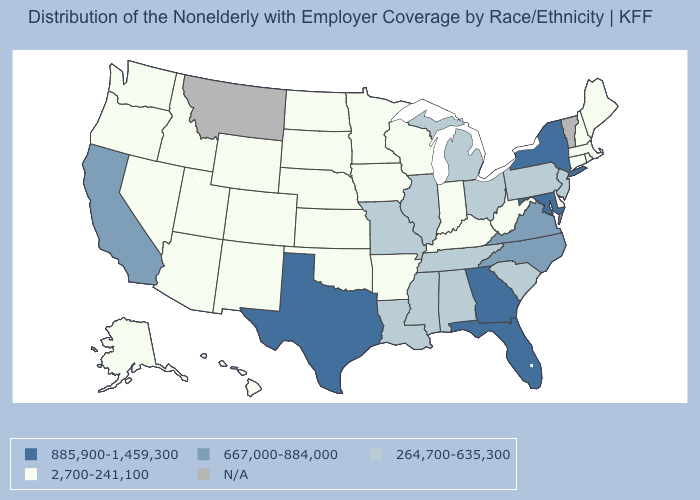Which states have the highest value in the USA?
Give a very brief answer. Florida, Georgia, Maryland, New York, Texas. What is the value of Pennsylvania?
Give a very brief answer. 264,700-635,300. What is the value of West Virginia?
Answer briefly. 2,700-241,100. Which states have the lowest value in the West?
Give a very brief answer. Alaska, Arizona, Colorado, Hawaii, Idaho, Nevada, New Mexico, Oregon, Utah, Washington, Wyoming. What is the highest value in the USA?
Give a very brief answer. 885,900-1,459,300. Name the states that have a value in the range 264,700-635,300?
Give a very brief answer. Alabama, Illinois, Louisiana, Michigan, Mississippi, Missouri, New Jersey, Ohio, Pennsylvania, South Carolina, Tennessee. Does the map have missing data?
Quick response, please. Yes. Among the states that border Massachusetts , which have the highest value?
Answer briefly. New York. Which states have the highest value in the USA?
Concise answer only. Florida, Georgia, Maryland, New York, Texas. Name the states that have a value in the range 667,000-884,000?
Be succinct. California, North Carolina, Virginia. What is the lowest value in the MidWest?
Give a very brief answer. 2,700-241,100. Does Georgia have the highest value in the USA?
Be succinct. Yes. 